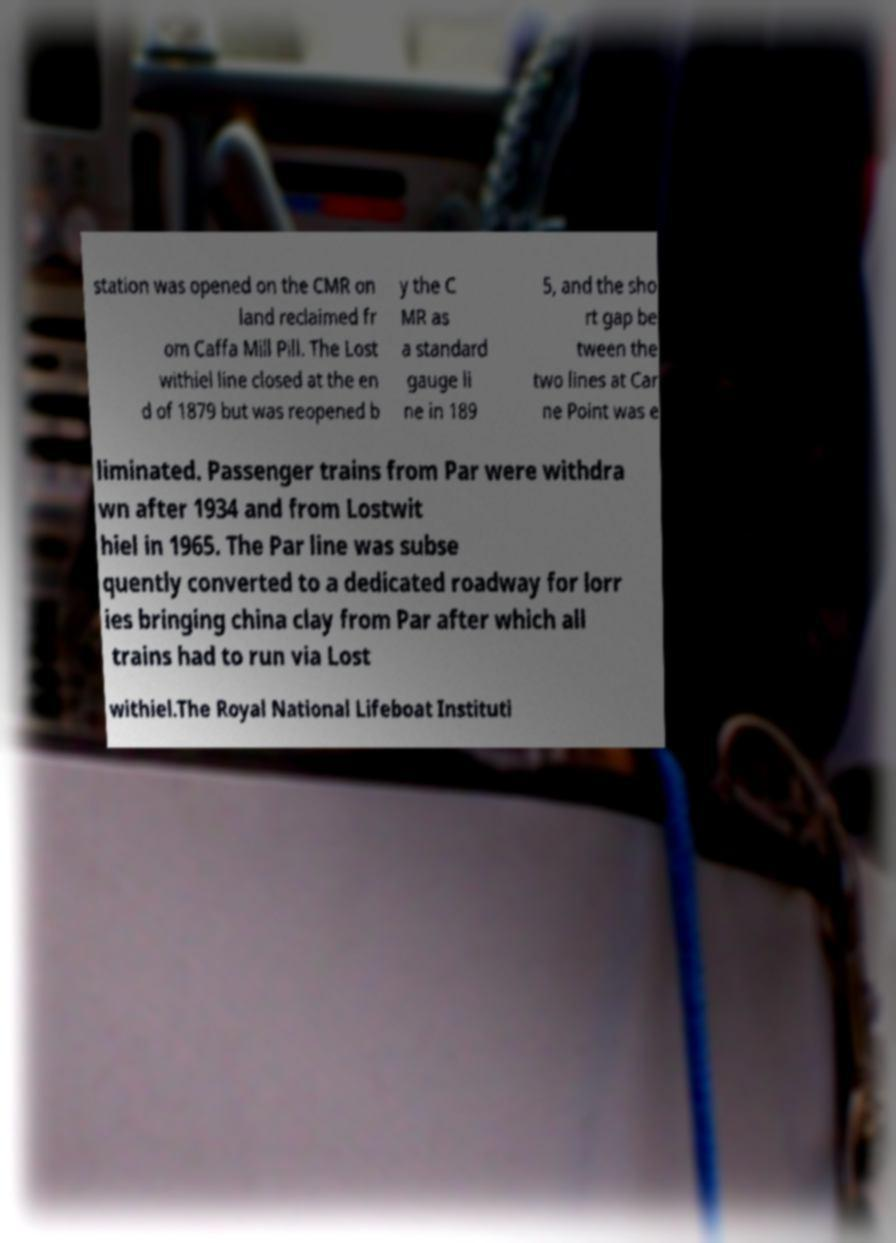I need the written content from this picture converted into text. Can you do that? station was opened on the CMR on land reclaimed fr om Caffa Mill Pill. The Lost withiel line closed at the en d of 1879 but was reopened b y the C MR as a standard gauge li ne in 189 5, and the sho rt gap be tween the two lines at Car ne Point was e liminated. Passenger trains from Par were withdra wn after 1934 and from Lostwit hiel in 1965. The Par line was subse quently converted to a dedicated roadway for lorr ies bringing china clay from Par after which all trains had to run via Lost withiel.The Royal National Lifeboat Instituti 